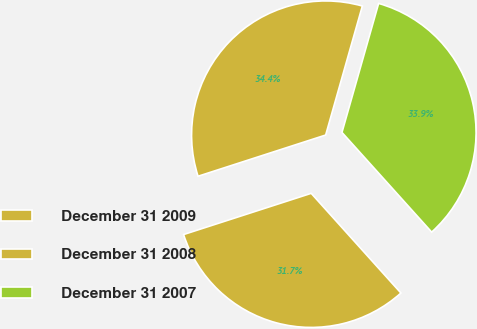<chart> <loc_0><loc_0><loc_500><loc_500><pie_chart><fcel>December 31 2009<fcel>December 31 2008<fcel>December 31 2007<nl><fcel>34.38%<fcel>31.69%<fcel>33.93%<nl></chart> 